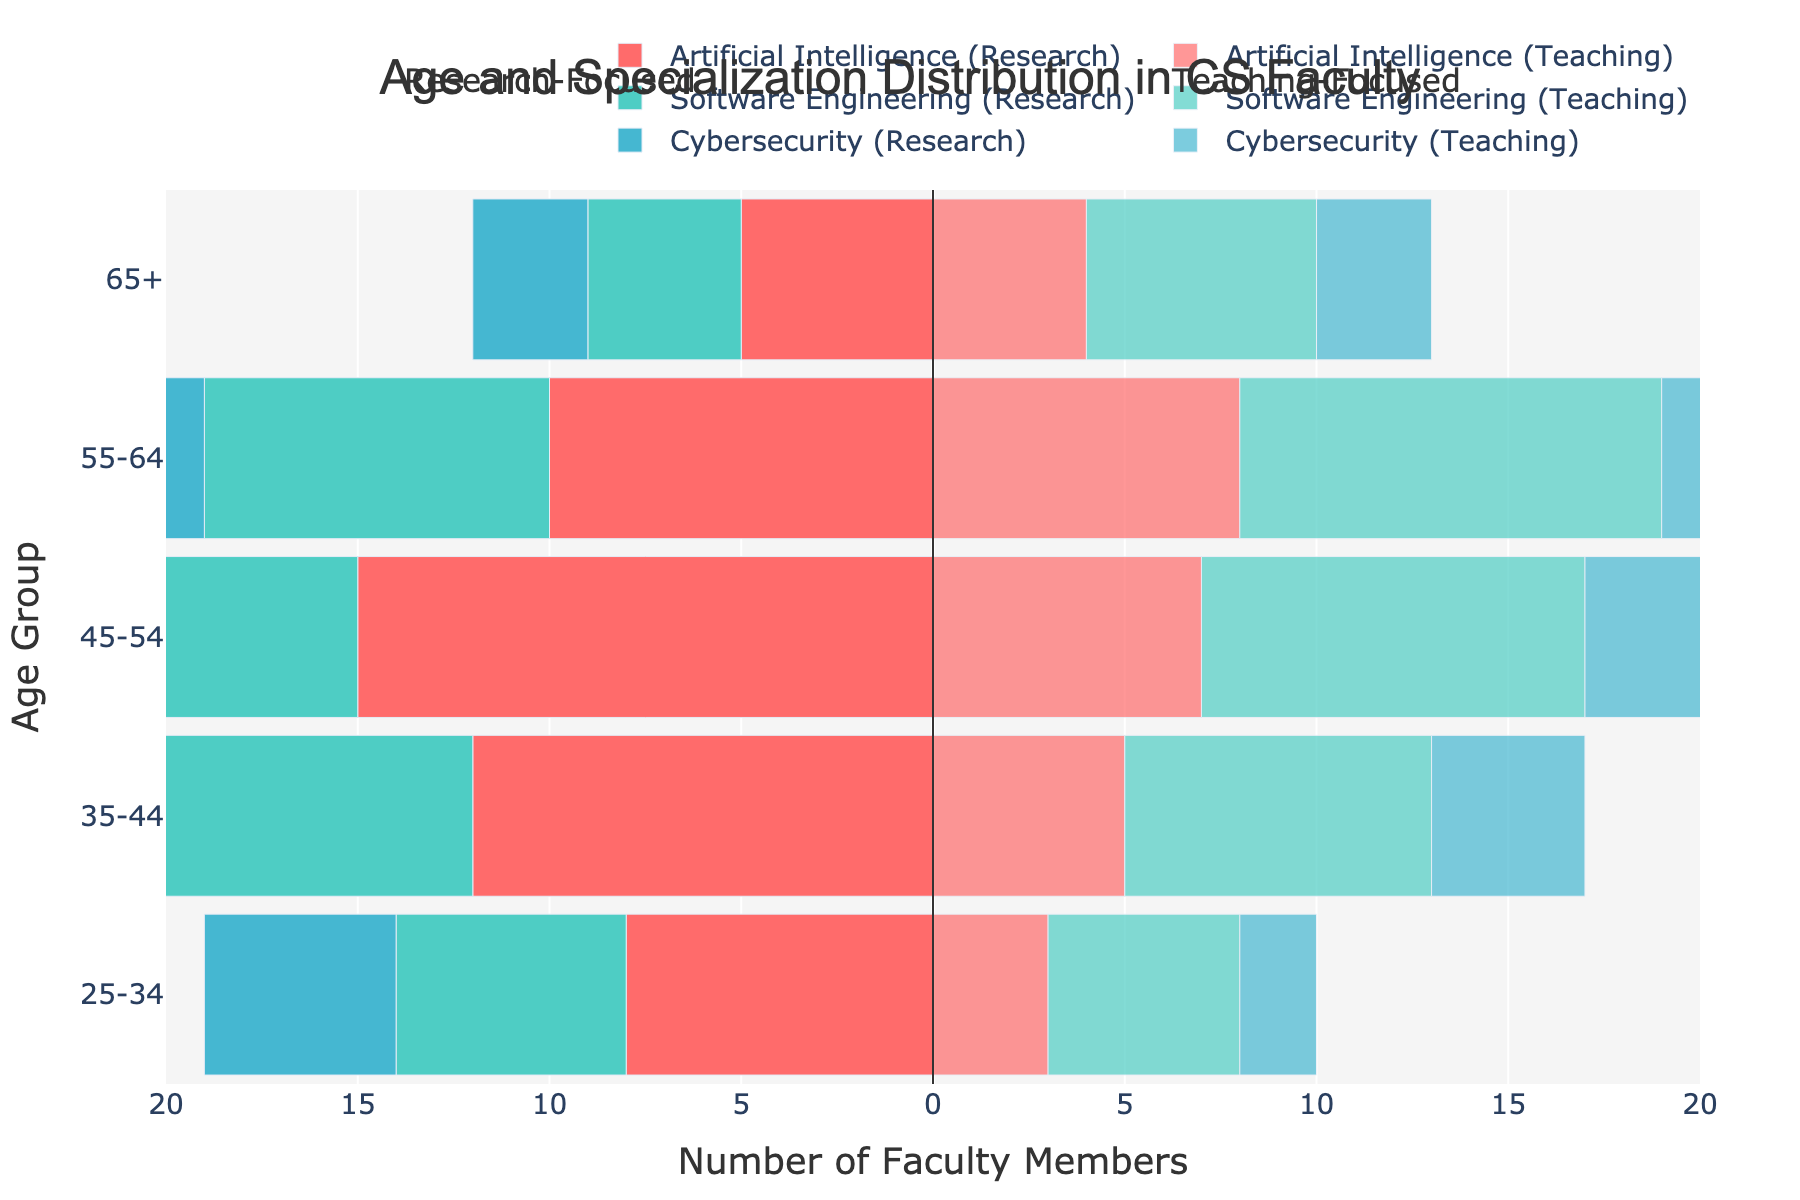What is the title of the figure? The title is usually located at the top of the figure and indicates what the figure is about. In this case, it reads "Age and Specialization Distribution in CS Faculty".
Answer: Age and Specialization Distribution in CS Faculty What is the age group with the highest number of research-focused faculty members in Artificial Intelligence? To find this, look at the bars corresponding to research-focused Artificial Intelligence faculty. The 45-54 age group has the longest bar of -15.
Answer: 45-54 Compare the number of teaching-focused faculty members specializing in Software Engineering aged 55-64 and those aged 65+. Which group has more faculty members? For Software Engineering teaching-focused, compare the lengths of the bars for 55-64 and 65+. The 55-64 group has 11 while the 65+ group has 6. So, 55-64 has more.
Answer: 55-64 What is the total number of research-focused faculty members in Cybersecurity across all age groups? Sum up the absolute values of the research-focused Cybersecurity bars: 5 (25-34) + 9 (35-44) + 11 (45-54) + 7 (55-64) + 3 (65+). Total is 5+9+11+7+3 = 35.
Answer: 35 What specialization in the 35-44 age group has the highest combined total of research-focused and teaching-focused faculty members? Combine the research and teaching values for each specialization in the 35-44 age group: AI (12+5), SE (10+8), CS (9+4). AI has 17, SE has 18, CS has 13. The highest is Software Engineering with 18.
Answer: Software Engineering How many more research-focused Artificial Intelligence faculty members are there in the 45-54 age group than teaching-focused ones? Research-focused AI in 45-54 have 15, and teaching-focused have 7. The difference is 15 - 7 = 8.
Answer: 8 What is the smallest number of faculty members in a single category (specialization and focus) in the oldest age group (65+)? Look at the 65+ group for the smallest number. Research-focused Cybersecurity has 3 faculty members.
Answer: 3 In the 25-34 age group, which specialization has the least number of teaching-focused faculty members? Compare the values for teaching-focused in the 25-34 age group: AI (3), SE (5), CS (2). Cybersecurity has the least.
Answer: Cybersecurity 